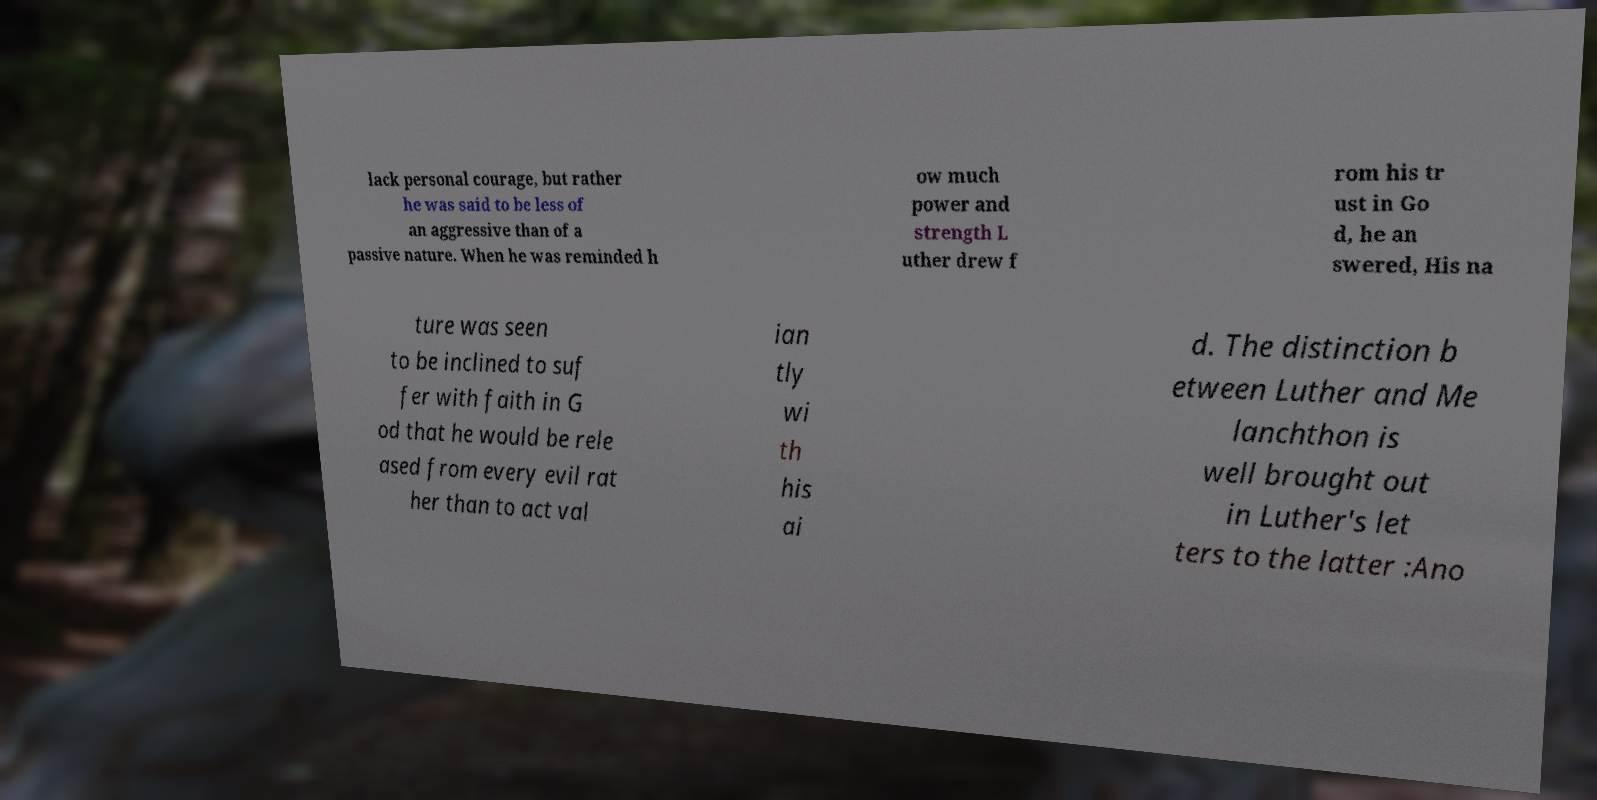Could you assist in decoding the text presented in this image and type it out clearly? lack personal courage, but rather he was said to be less of an aggressive than of a passive nature. When he was reminded h ow much power and strength L uther drew f rom his tr ust in Go d, he an swered, His na ture was seen to be inclined to suf fer with faith in G od that he would be rele ased from every evil rat her than to act val ian tly wi th his ai d. The distinction b etween Luther and Me lanchthon is well brought out in Luther's let ters to the latter :Ano 